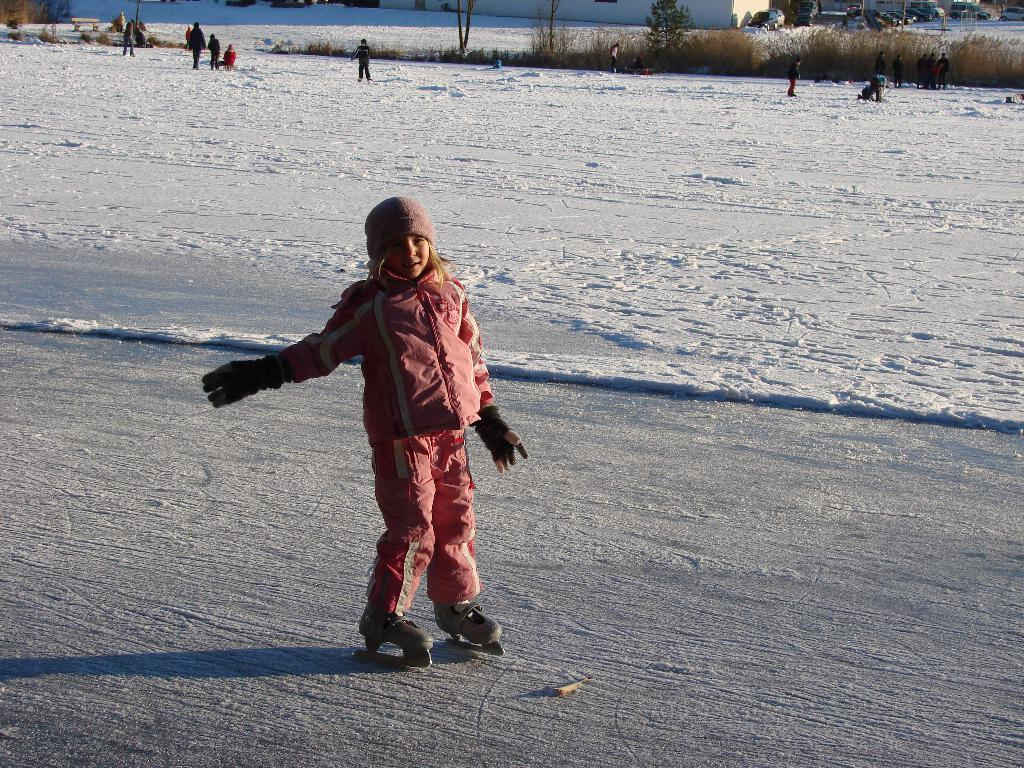Who is the main subject in the image? There is a girl in the image. What clothing items is the girl wearing? The girl is wearing gloves, skating shoes, and a cap. What is the weather like in the image? There is snow in the image, indicating a cold or wintery environment. What can be seen in the background of the image? There are people, poles, a wall, plants, and vehicles in the background of the image. What type of volleyball is the girl playing in the image? There is no volleyball present in the image; the girl is wearing skating shoes and gloves, suggesting a winter sport like ice skating. What is the connection between the girl and the plants in the background? There is no direct connection between the girl and the plants in the background; they are simply elements in the same scene. 